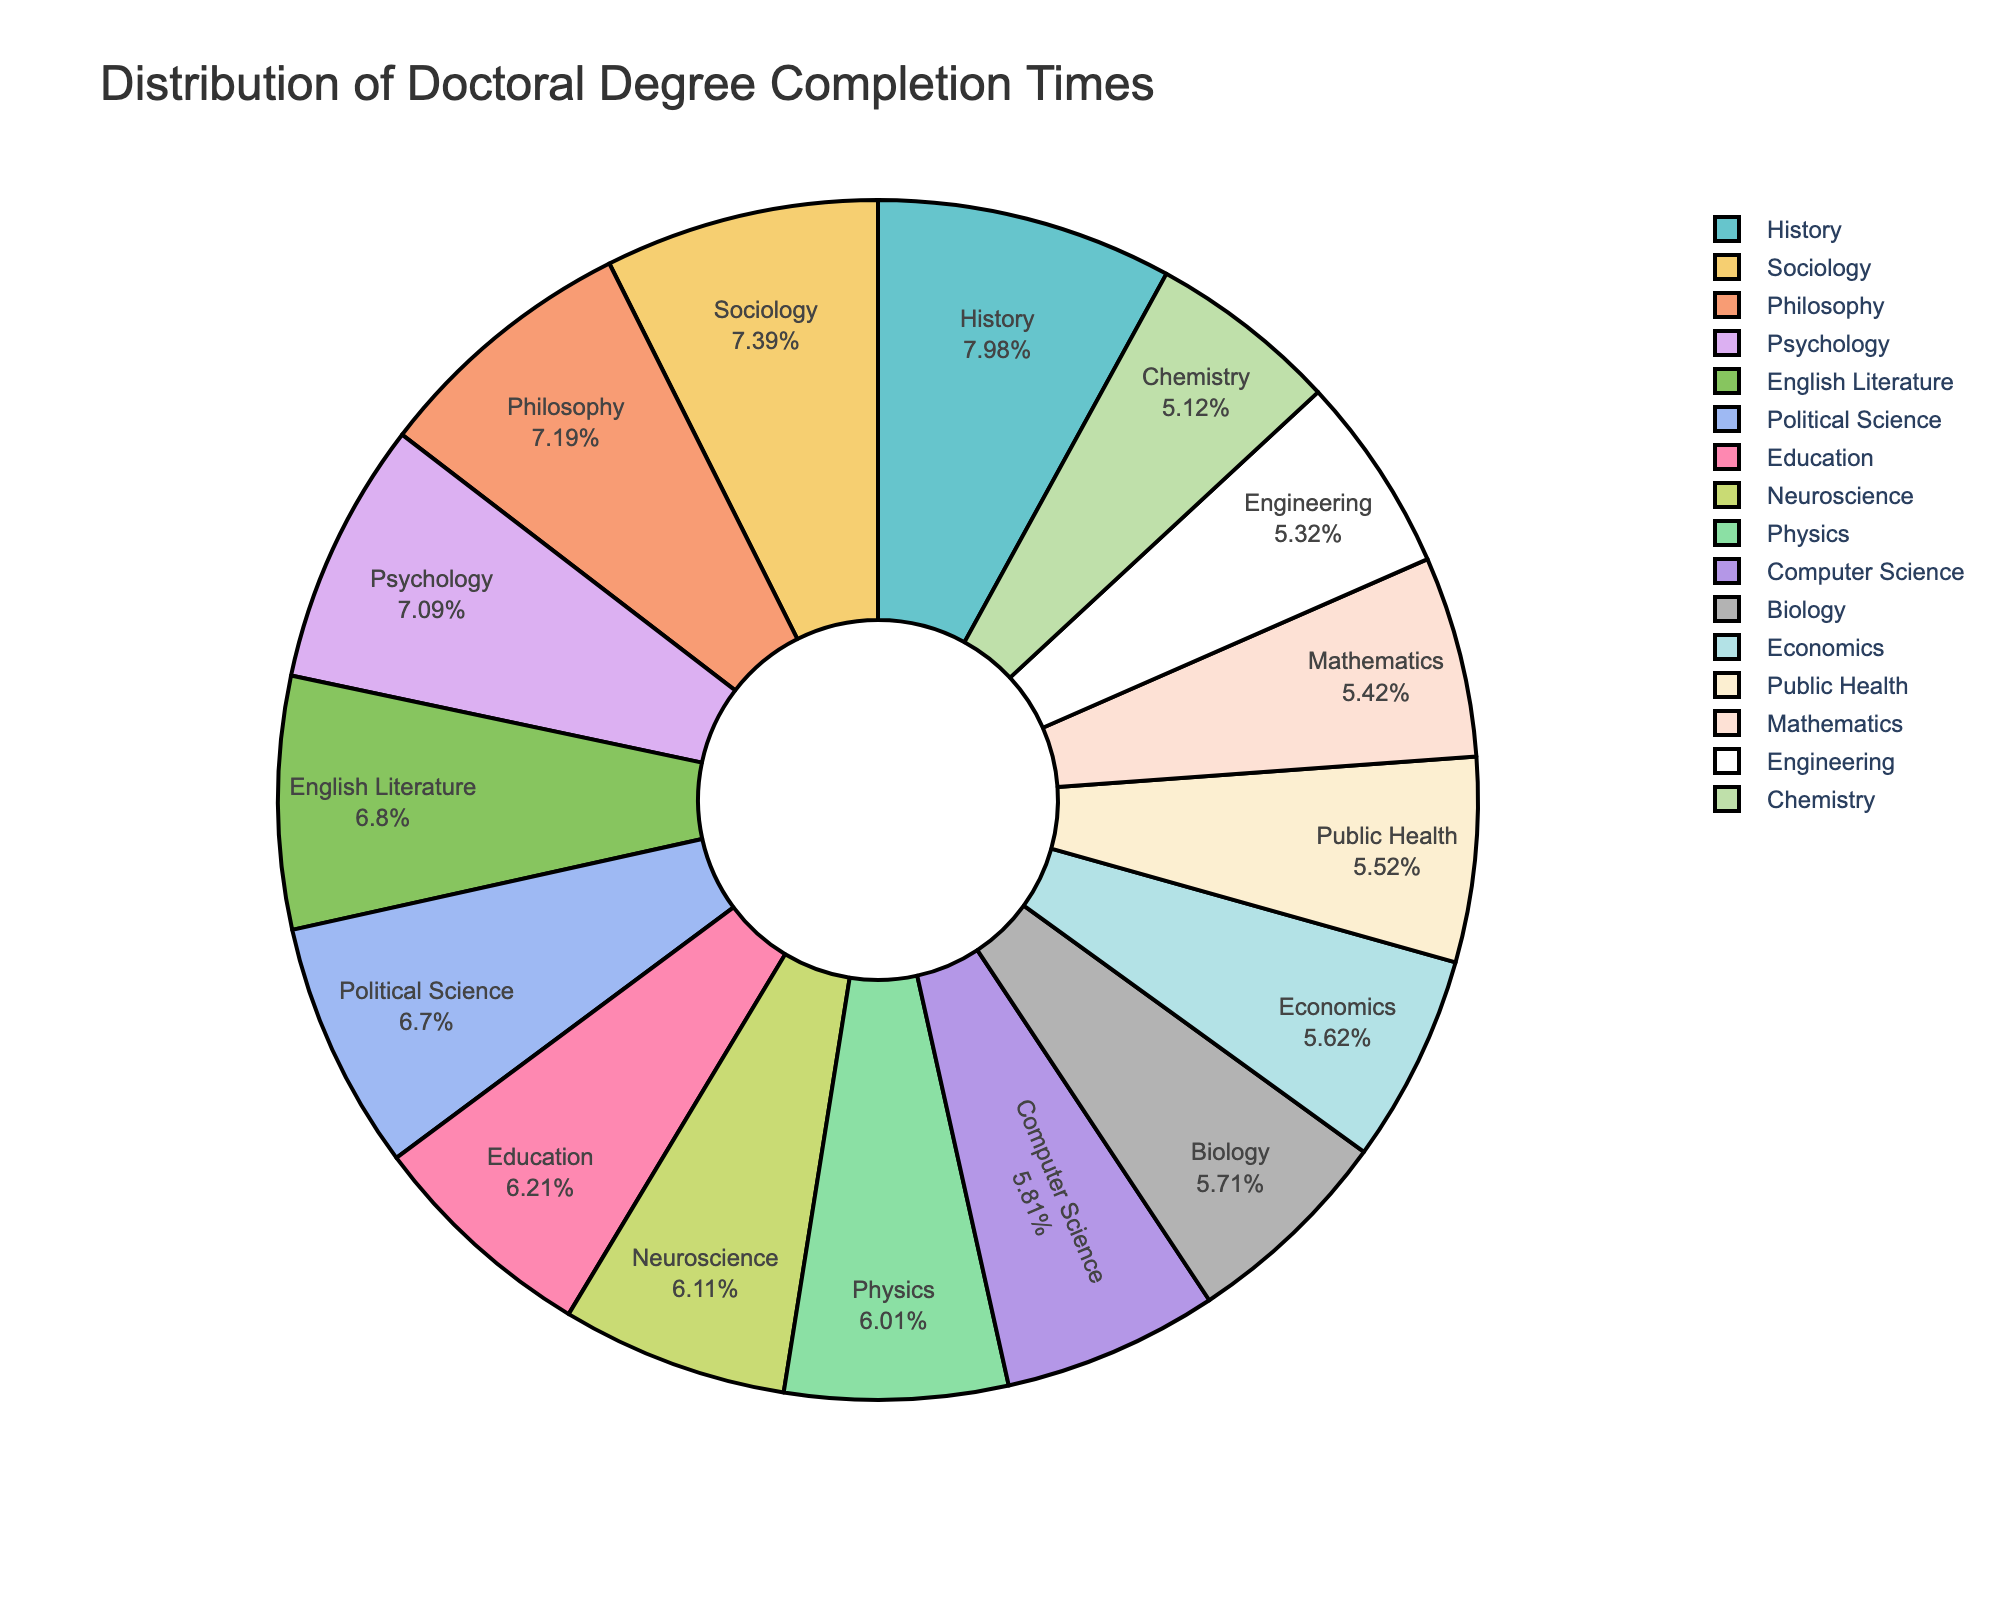Which field has the highest average completion time? Looking at the largest slice, it is labeled "History" with 8.1 years.
Answer: History How does the average completion time of Biology compare to that of Chemistry? Biology has an average completion time of 5.8 years while Chemistry has 5.2 years. Biology takes 0.6 years longer on average.
Answer: Biology takes longer What is the combined average completion time for Sociology and Psychology? Sociology has an average completion time of 7.5 years and Psychology has 7.2 years. Their combined time is 7.5 + 7.2 = 14.7 years.
Answer: 14.7 years Which field has a shorter average completion time, Philosophy or Education? Philosophy has an average completion time of 7.3 years while Education has 6.3 years. Education is shorter.
Answer: Education Are there any fields with an average completion time greater than 7 years? Yes, Sociology (7.5 years), Psychology (7.2 years), Political Science (6.8 years), History (8.1 years), English Literature (6.9 years), and Philosophy (7.3 years).
Answer: Yes What percentage of the total average completion time does Engineering contribute? Engineering has a completion time of 5.4 years. Sum of all times is 99.5 years. The percentage is (5.4 / 99.5) * 100 ≈ 5.43%.
Answer: ~5.43% What's the difference in average completion time between Political Science and Computer Science? Political Science has 6.8 years, and Computer Science has 5.9 years. The difference is 6.8 - 5.9 = 0.9 years.
Answer: 0.9 years Which field has the smallest slice in the pie chart? The smallest slice is for Chemistry, which has an average completion time of 5.2 years.
Answer: Chemistry How does the average completion time of Public Health compare to that of Mathematics and Neuroscience combined? Public Health has 5.6 years. Mathematics has 5.5 years and Neuroscience has 6.2 years. Combined, they have 5.5 + 6.2 = 11.7 years, which is significantly longer than Public Health.
Answer: Public Health is less Is the average completion time for Computer Science closer to that of Biology or Neuroscience? Computer Science has 5.9 years, Biology has 5.8 years, and Neuroscience has 6.2 years. Computer Science is closer to Biology (difference 0.1 years) than Neuroscience (difference 0.3 years).
Answer: Biology 